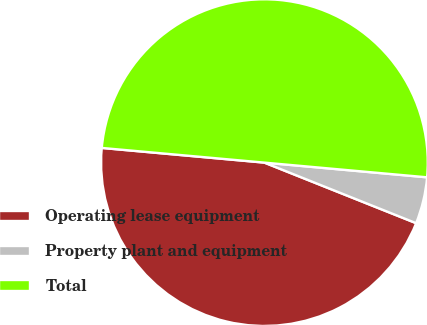<chart> <loc_0><loc_0><loc_500><loc_500><pie_chart><fcel>Operating lease equipment<fcel>Property plant and equipment<fcel>Total<nl><fcel>45.39%<fcel>4.61%<fcel>50.0%<nl></chart> 